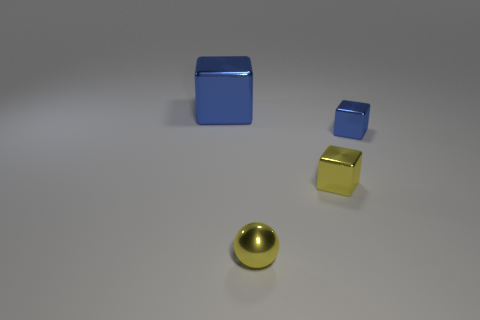What number of small blue blocks are in front of the small blue metallic cube?
Provide a succinct answer. 0. What color is the sphere that is in front of the blue thing to the left of the shiny sphere?
Provide a succinct answer. Yellow. Is there anything else that has the same shape as the large blue thing?
Keep it short and to the point. Yes. Is the number of tiny yellow shiny balls in front of the large metal cube the same as the number of big blue shiny objects that are in front of the shiny ball?
Offer a terse response. No. What number of cylinders are either small purple rubber objects or tiny blue shiny objects?
Give a very brief answer. 0. What number of other objects are the same material as the big block?
Provide a short and direct response. 3. What is the shape of the tiny yellow thing behind the metal ball?
Ensure brevity in your answer.  Cube. What is the cube behind the blue block in front of the large blue metal object made of?
Offer a very short reply. Metal. Are there more tiny cubes in front of the small yellow metal cube than cubes?
Ensure brevity in your answer.  No. How many other objects are the same color as the metal sphere?
Your response must be concise. 1. 